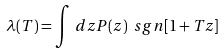Convert formula to latex. <formula><loc_0><loc_0><loc_500><loc_500>\lambda ( T ) = \int \, d z P ( z ) \ s g n [ 1 + T z ]</formula> 